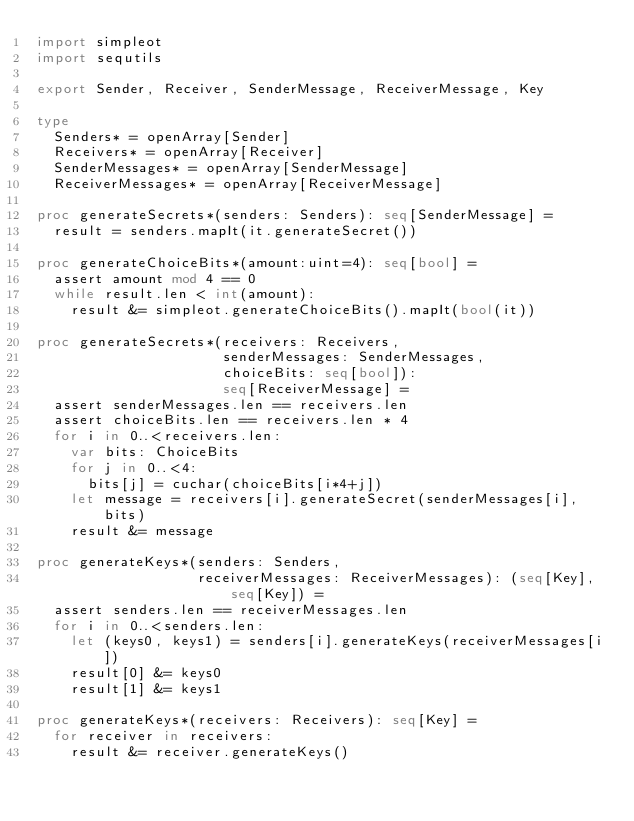Convert code to text. <code><loc_0><loc_0><loc_500><loc_500><_Nim_>import simpleot
import sequtils

export Sender, Receiver, SenderMessage, ReceiverMessage, Key

type
  Senders* = openArray[Sender]
  Receivers* = openArray[Receiver]
  SenderMessages* = openArray[SenderMessage]
  ReceiverMessages* = openArray[ReceiverMessage]

proc generateSecrets*(senders: Senders): seq[SenderMessage] =
  result = senders.mapIt(it.generateSecret())

proc generateChoiceBits*(amount:uint=4): seq[bool] =
  assert amount mod 4 == 0
  while result.len < int(amount):
    result &= simpleot.generateChoiceBits().mapIt(bool(it))

proc generateSecrets*(receivers: Receivers,
                      senderMessages: SenderMessages,
                      choiceBits: seq[bool]):
                      seq[ReceiverMessage] =
  assert senderMessages.len == receivers.len
  assert choiceBits.len == receivers.len * 4
  for i in 0..<receivers.len:
    var bits: ChoiceBits
    for j in 0..<4:
      bits[j] = cuchar(choiceBits[i*4+j])
    let message = receivers[i].generateSecret(senderMessages[i], bits)
    result &= message

proc generateKeys*(senders: Senders,
                   receiverMessages: ReceiverMessages): (seq[Key], seq[Key]) =
  assert senders.len == receiverMessages.len
  for i in 0..<senders.len:
    let (keys0, keys1) = senders[i].generateKeys(receiverMessages[i])
    result[0] &= keys0
    result[1] &= keys1

proc generateKeys*(receivers: Receivers): seq[Key] =
  for receiver in receivers:
    result &= receiver.generateKeys()
</code> 